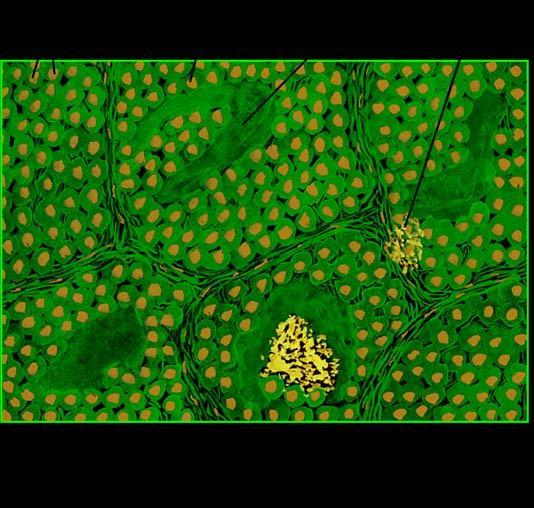what does microscopy show?
Answer the question using a single word or phrase. Organoid pattern of oval tumour cells and abundant amyloid stroma 